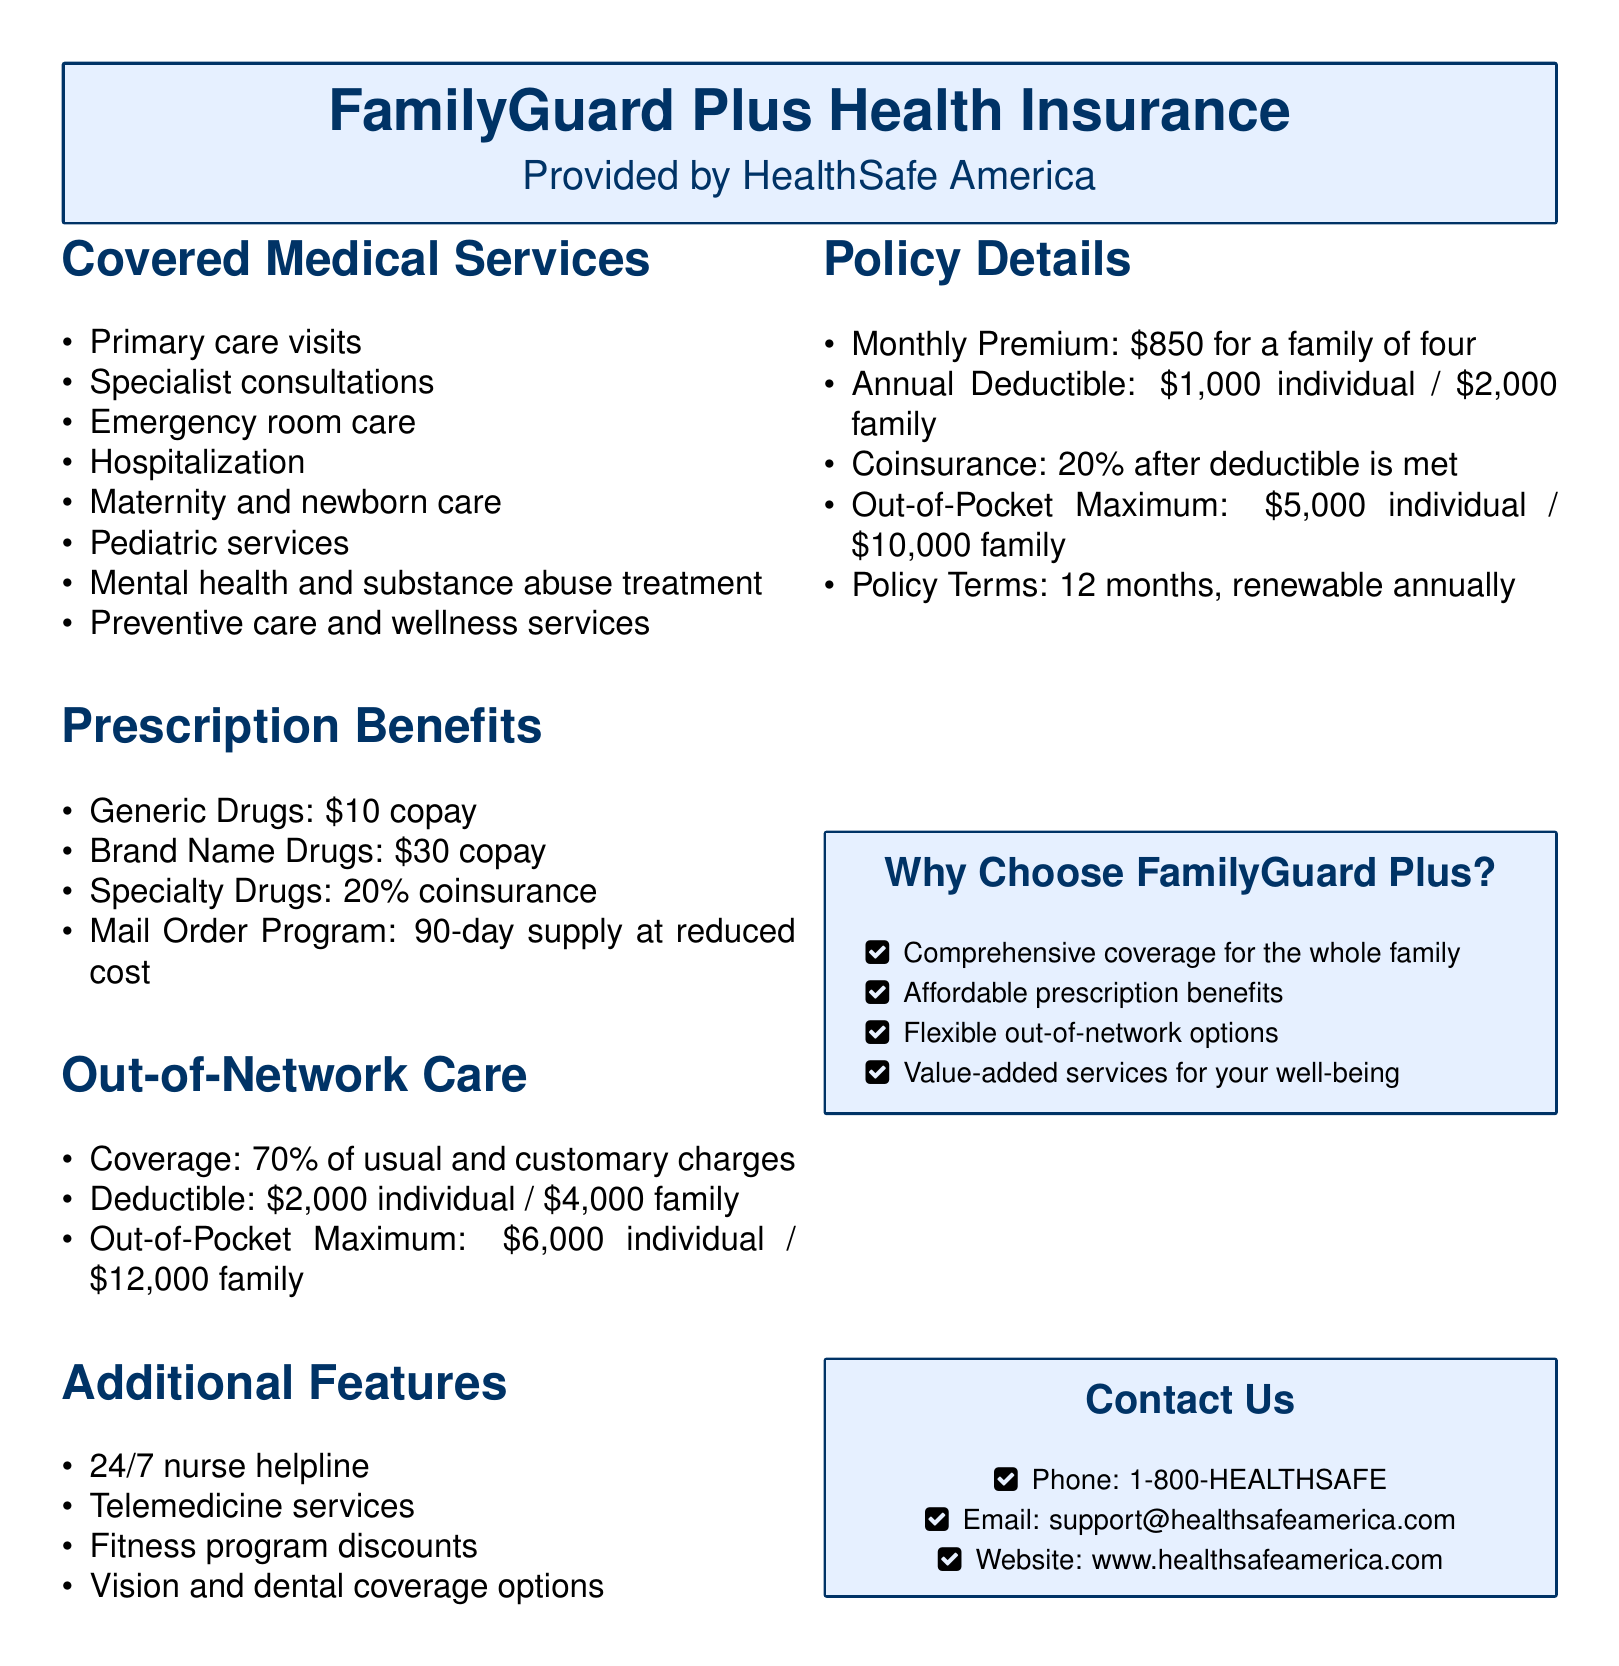What are the primary care visit copayments? The document states the copayment for primary care visits under the prescription benefits section.
Answer: $10 What percentage of charges is covered for out-of-network care? The document provides details under the out-of-network care section regarding coverage.
Answer: 70% What is the annual deductible for a family? The policy details section specifies the annual deductible for a family.
Answer: $2,000 How much is the monthly premium for a family of four? The policy details section lists the monthly premium amount.
Answer: $850 What is covered under preventive care services? The document specifies what types of medical services are included in preventive care and wellness services.
Answer: Preventive care and wellness services What is the out-of-pocket maximum for an individual? The out-of-pocket maximum is specified in the policy details section.
Answer: $5,000 What additional features are included in the policy? The document lists various value-added features available with the health insurance policy.
Answer: 24/7 nurse helpline, Telemedicine services, Fitness program discounts, Vision and dental coverage options What is the coinsurance rate after the deductible is met? Information regarding coinsurance is provided in the policy details section of the document.
Answer: 20% What is the contact number for customer support? The document provides contact information including a phone number for customer inquiries.
Answer: 1-800-HEALTHSAFE 